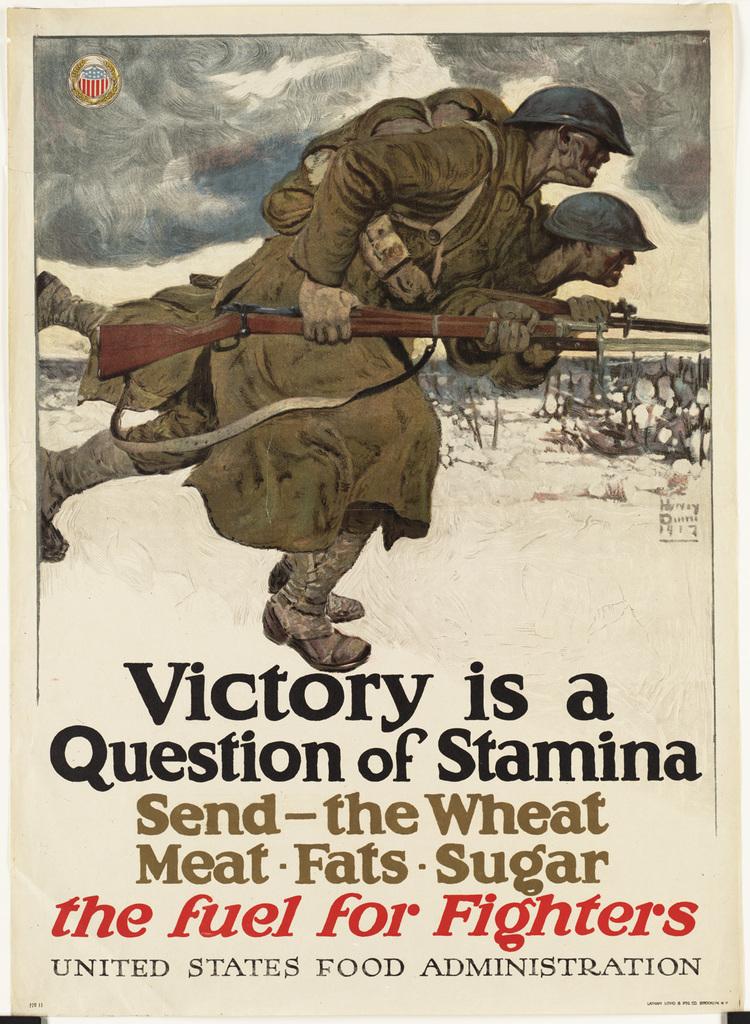What is victory a question of?
Offer a very short reply. Stamina. What country is this from?
Give a very brief answer. United states. 